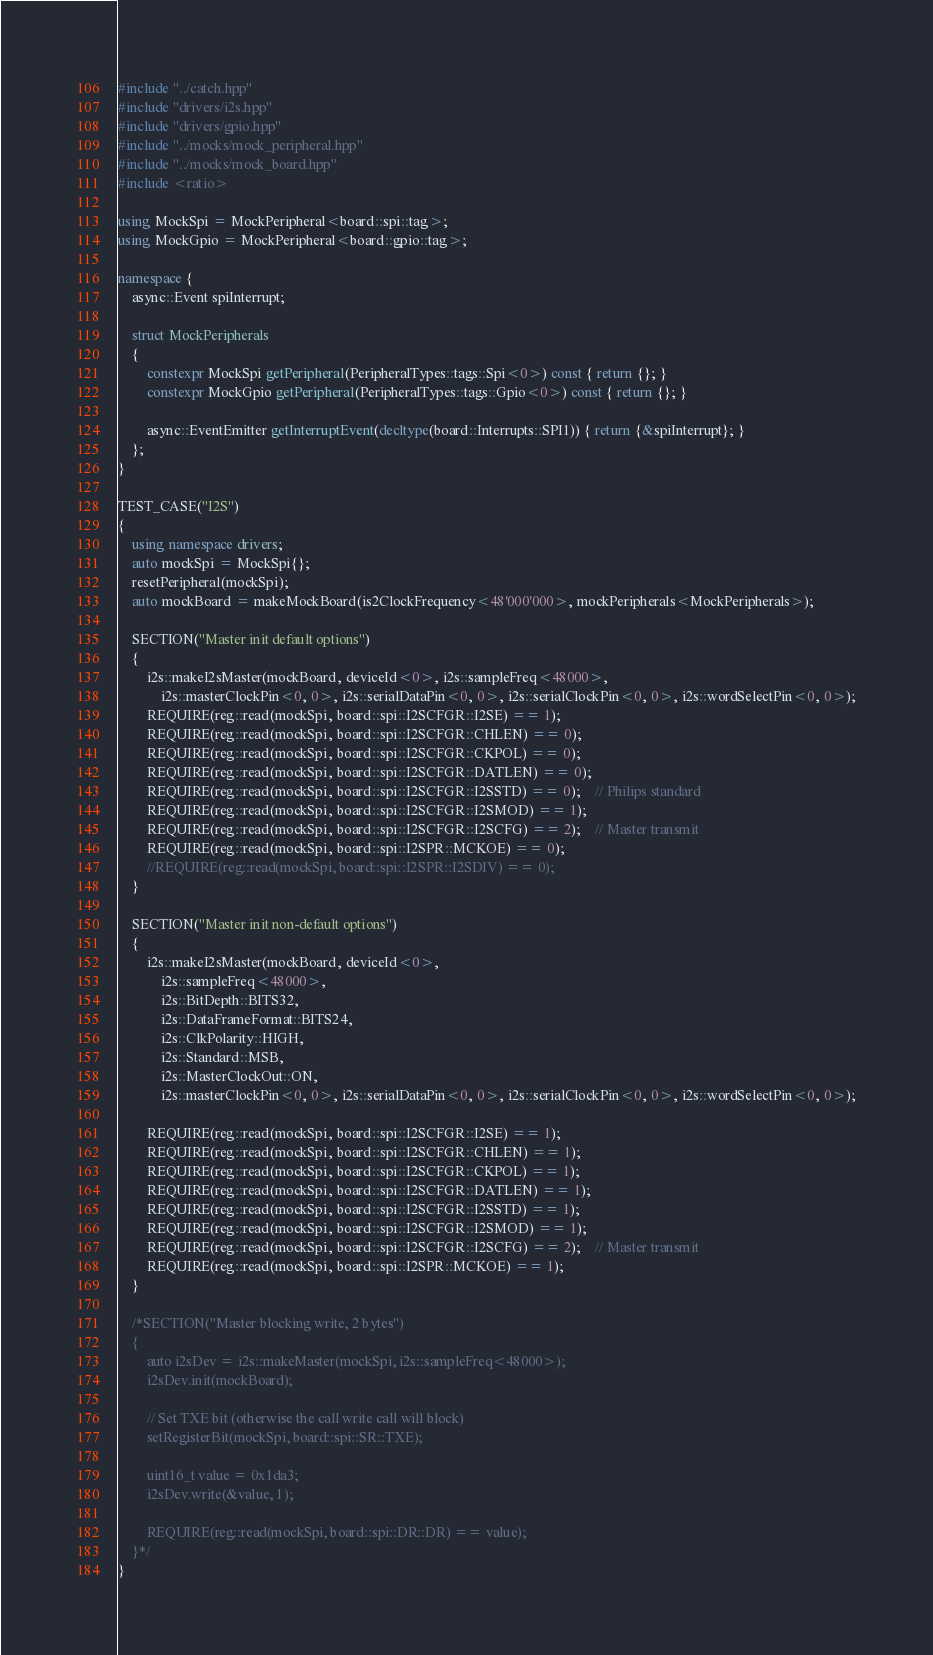Convert code to text. <code><loc_0><loc_0><loc_500><loc_500><_C++_>#include "../catch.hpp"
#include "drivers/i2s.hpp"
#include "drivers/gpio.hpp"
#include "../mocks/mock_peripheral.hpp"
#include "../mocks/mock_board.hpp"
#include <ratio>

using MockSpi = MockPeripheral<board::spi::tag>;
using MockGpio = MockPeripheral<board::gpio::tag>;

namespace {
    async::Event spiInterrupt;

    struct MockPeripherals
    {
        constexpr MockSpi getPeripheral(PeripheralTypes::tags::Spi<0>) const { return {}; }
        constexpr MockGpio getPeripheral(PeripheralTypes::tags::Gpio<0>) const { return {}; }

        async::EventEmitter getInterruptEvent(decltype(board::Interrupts::SPI1)) { return {&spiInterrupt}; }
    };
}

TEST_CASE("I2S")
{
    using namespace drivers;
    auto mockSpi = MockSpi{};
    resetPeripheral(mockSpi);
    auto mockBoard = makeMockBoard(is2ClockFrequency<48'000'000>, mockPeripherals<MockPeripherals>);

    SECTION("Master init default options")
    {
        i2s::makeI2sMaster(mockBoard, deviceId<0>, i2s::sampleFreq<48000>, 
            i2s::masterClockPin<0, 0>, i2s::serialDataPin<0, 0>, i2s::serialClockPin<0, 0>, i2s::wordSelectPin<0, 0>);
        REQUIRE(reg::read(mockSpi, board::spi::I2SCFGR::I2SE) == 1);
        REQUIRE(reg::read(mockSpi, board::spi::I2SCFGR::CHLEN) == 0);
        REQUIRE(reg::read(mockSpi, board::spi::I2SCFGR::CKPOL) == 0);
        REQUIRE(reg::read(mockSpi, board::spi::I2SCFGR::DATLEN) == 0);
        REQUIRE(reg::read(mockSpi, board::spi::I2SCFGR::I2SSTD) == 0);    // Philips standard
        REQUIRE(reg::read(mockSpi, board::spi::I2SCFGR::I2SMOD) == 1);
        REQUIRE(reg::read(mockSpi, board::spi::I2SCFGR::I2SCFG) == 2);    // Master transmit
        REQUIRE(reg::read(mockSpi, board::spi::I2SPR::MCKOE) == 0);
        //REQUIRE(reg::read(mockSpi, board::spi::I2SPR::I2SDIV) == 0);
    }

    SECTION("Master init non-default options")
    {
        i2s::makeI2sMaster(mockBoard, deviceId<0>, 
            i2s::sampleFreq<48000>,
            i2s::BitDepth::BITS32, 
            i2s::DataFrameFormat::BITS24,
            i2s::ClkPolarity::HIGH,
            i2s::Standard::MSB,
            i2s::MasterClockOut::ON,
            i2s::masterClockPin<0, 0>, i2s::serialDataPin<0, 0>, i2s::serialClockPin<0, 0>, i2s::wordSelectPin<0, 0>);

        REQUIRE(reg::read(mockSpi, board::spi::I2SCFGR::I2SE) == 1);
        REQUIRE(reg::read(mockSpi, board::spi::I2SCFGR::CHLEN) == 1);
        REQUIRE(reg::read(mockSpi, board::spi::I2SCFGR::CKPOL) == 1);
        REQUIRE(reg::read(mockSpi, board::spi::I2SCFGR::DATLEN) == 1);
        REQUIRE(reg::read(mockSpi, board::spi::I2SCFGR::I2SSTD) == 1);
        REQUIRE(reg::read(mockSpi, board::spi::I2SCFGR::I2SMOD) == 1);
        REQUIRE(reg::read(mockSpi, board::spi::I2SCFGR::I2SCFG) == 2);    // Master transmit
        REQUIRE(reg::read(mockSpi, board::spi::I2SPR::MCKOE) == 1);
    }

    /*SECTION("Master blocking write, 2 bytes")
    {
        auto i2sDev = i2s::makeMaster(mockSpi, i2s::sampleFreq<48000>);
        i2sDev.init(mockBoard);

        // Set TXE bit (otherwise the call write call will block)
        setRegisterBit(mockSpi, board::spi::SR::TXE);

        uint16_t value = 0x1da3;
        i2sDev.write(&value, 1);

        REQUIRE(reg::read(mockSpi, board::spi::DR::DR) == value);
    }*/
}</code> 